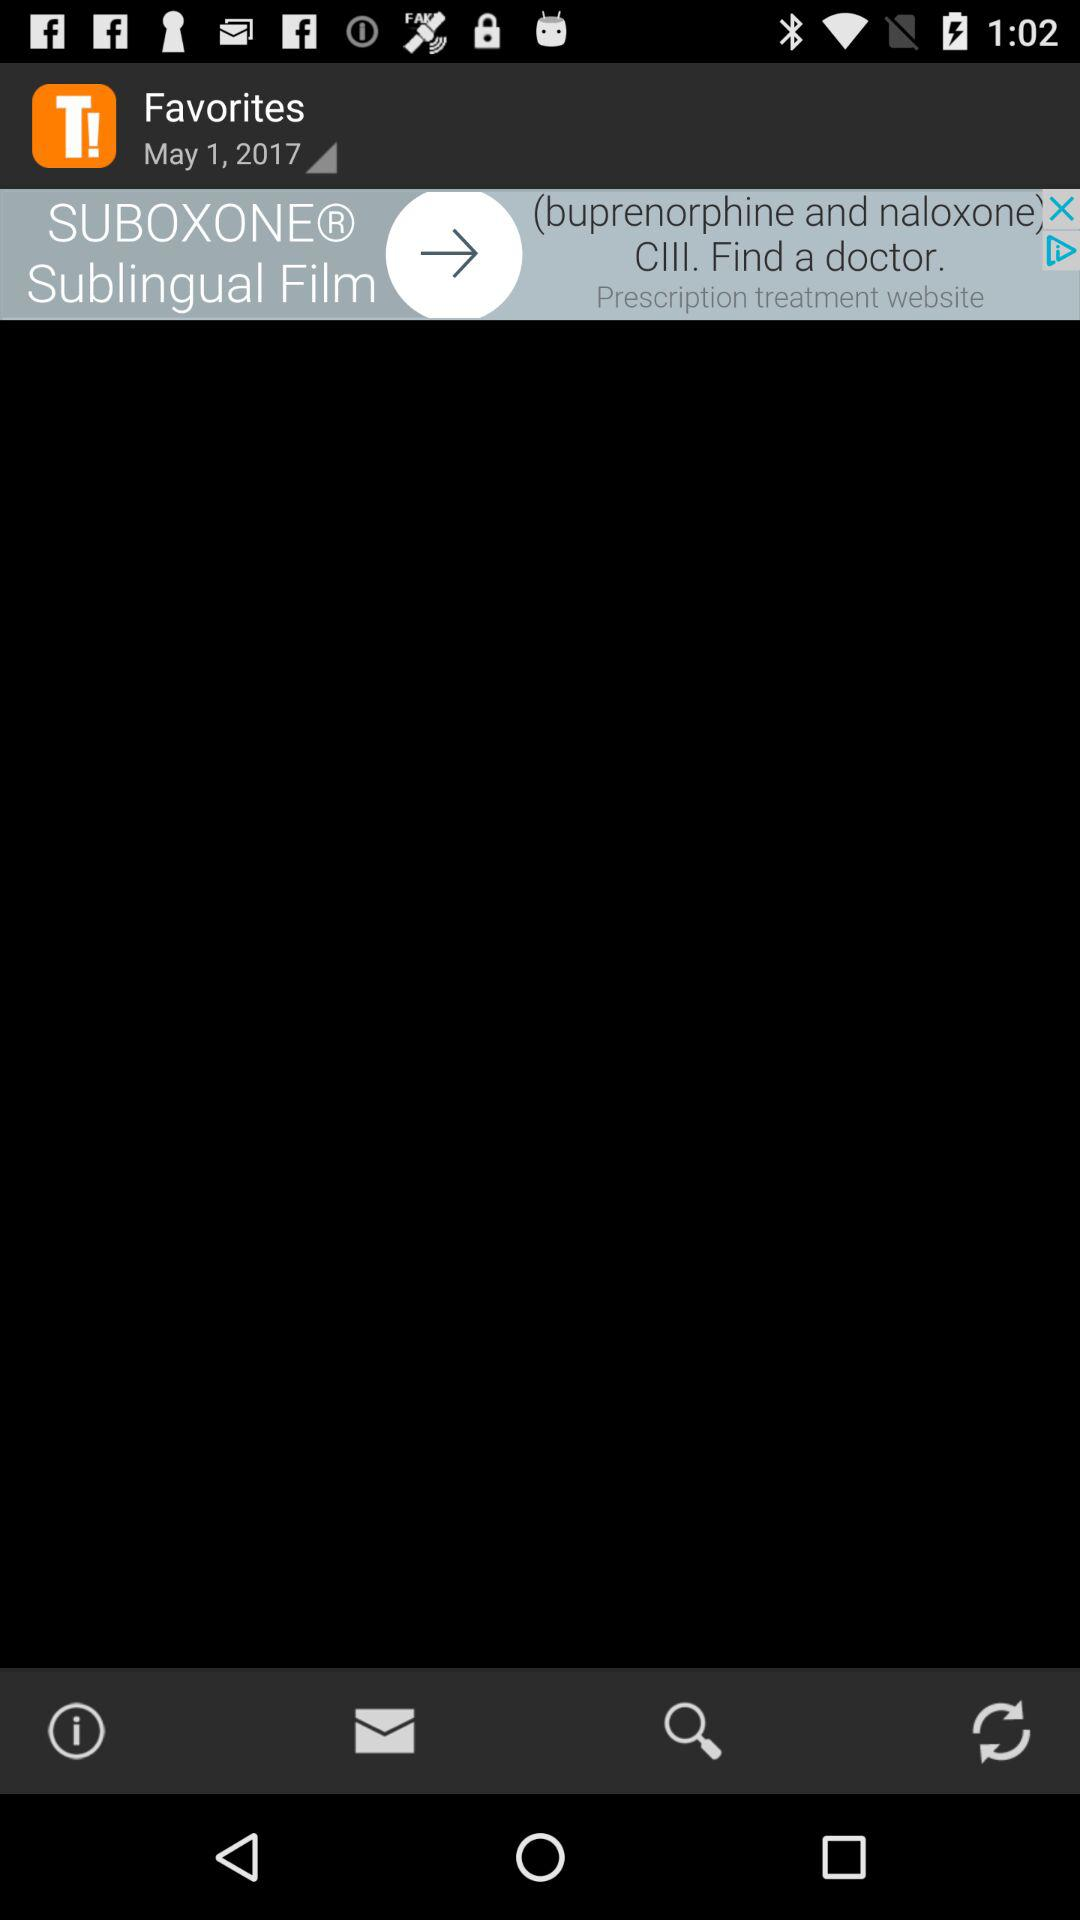What is the selected date in "Favorites"? The selected date is May 1, 2017. 